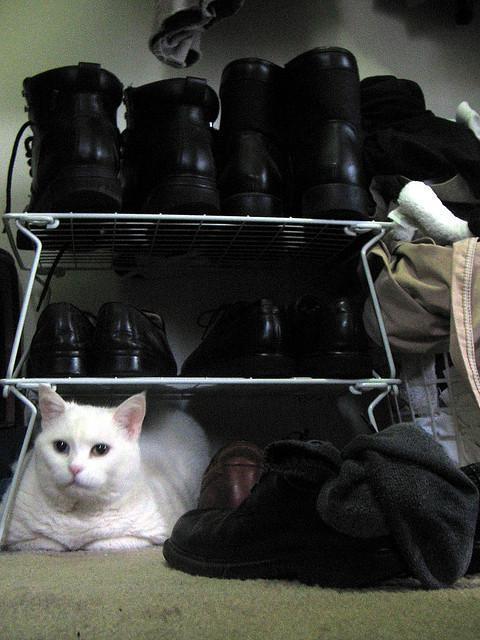How many slices of cake are there?
Give a very brief answer. 0. 